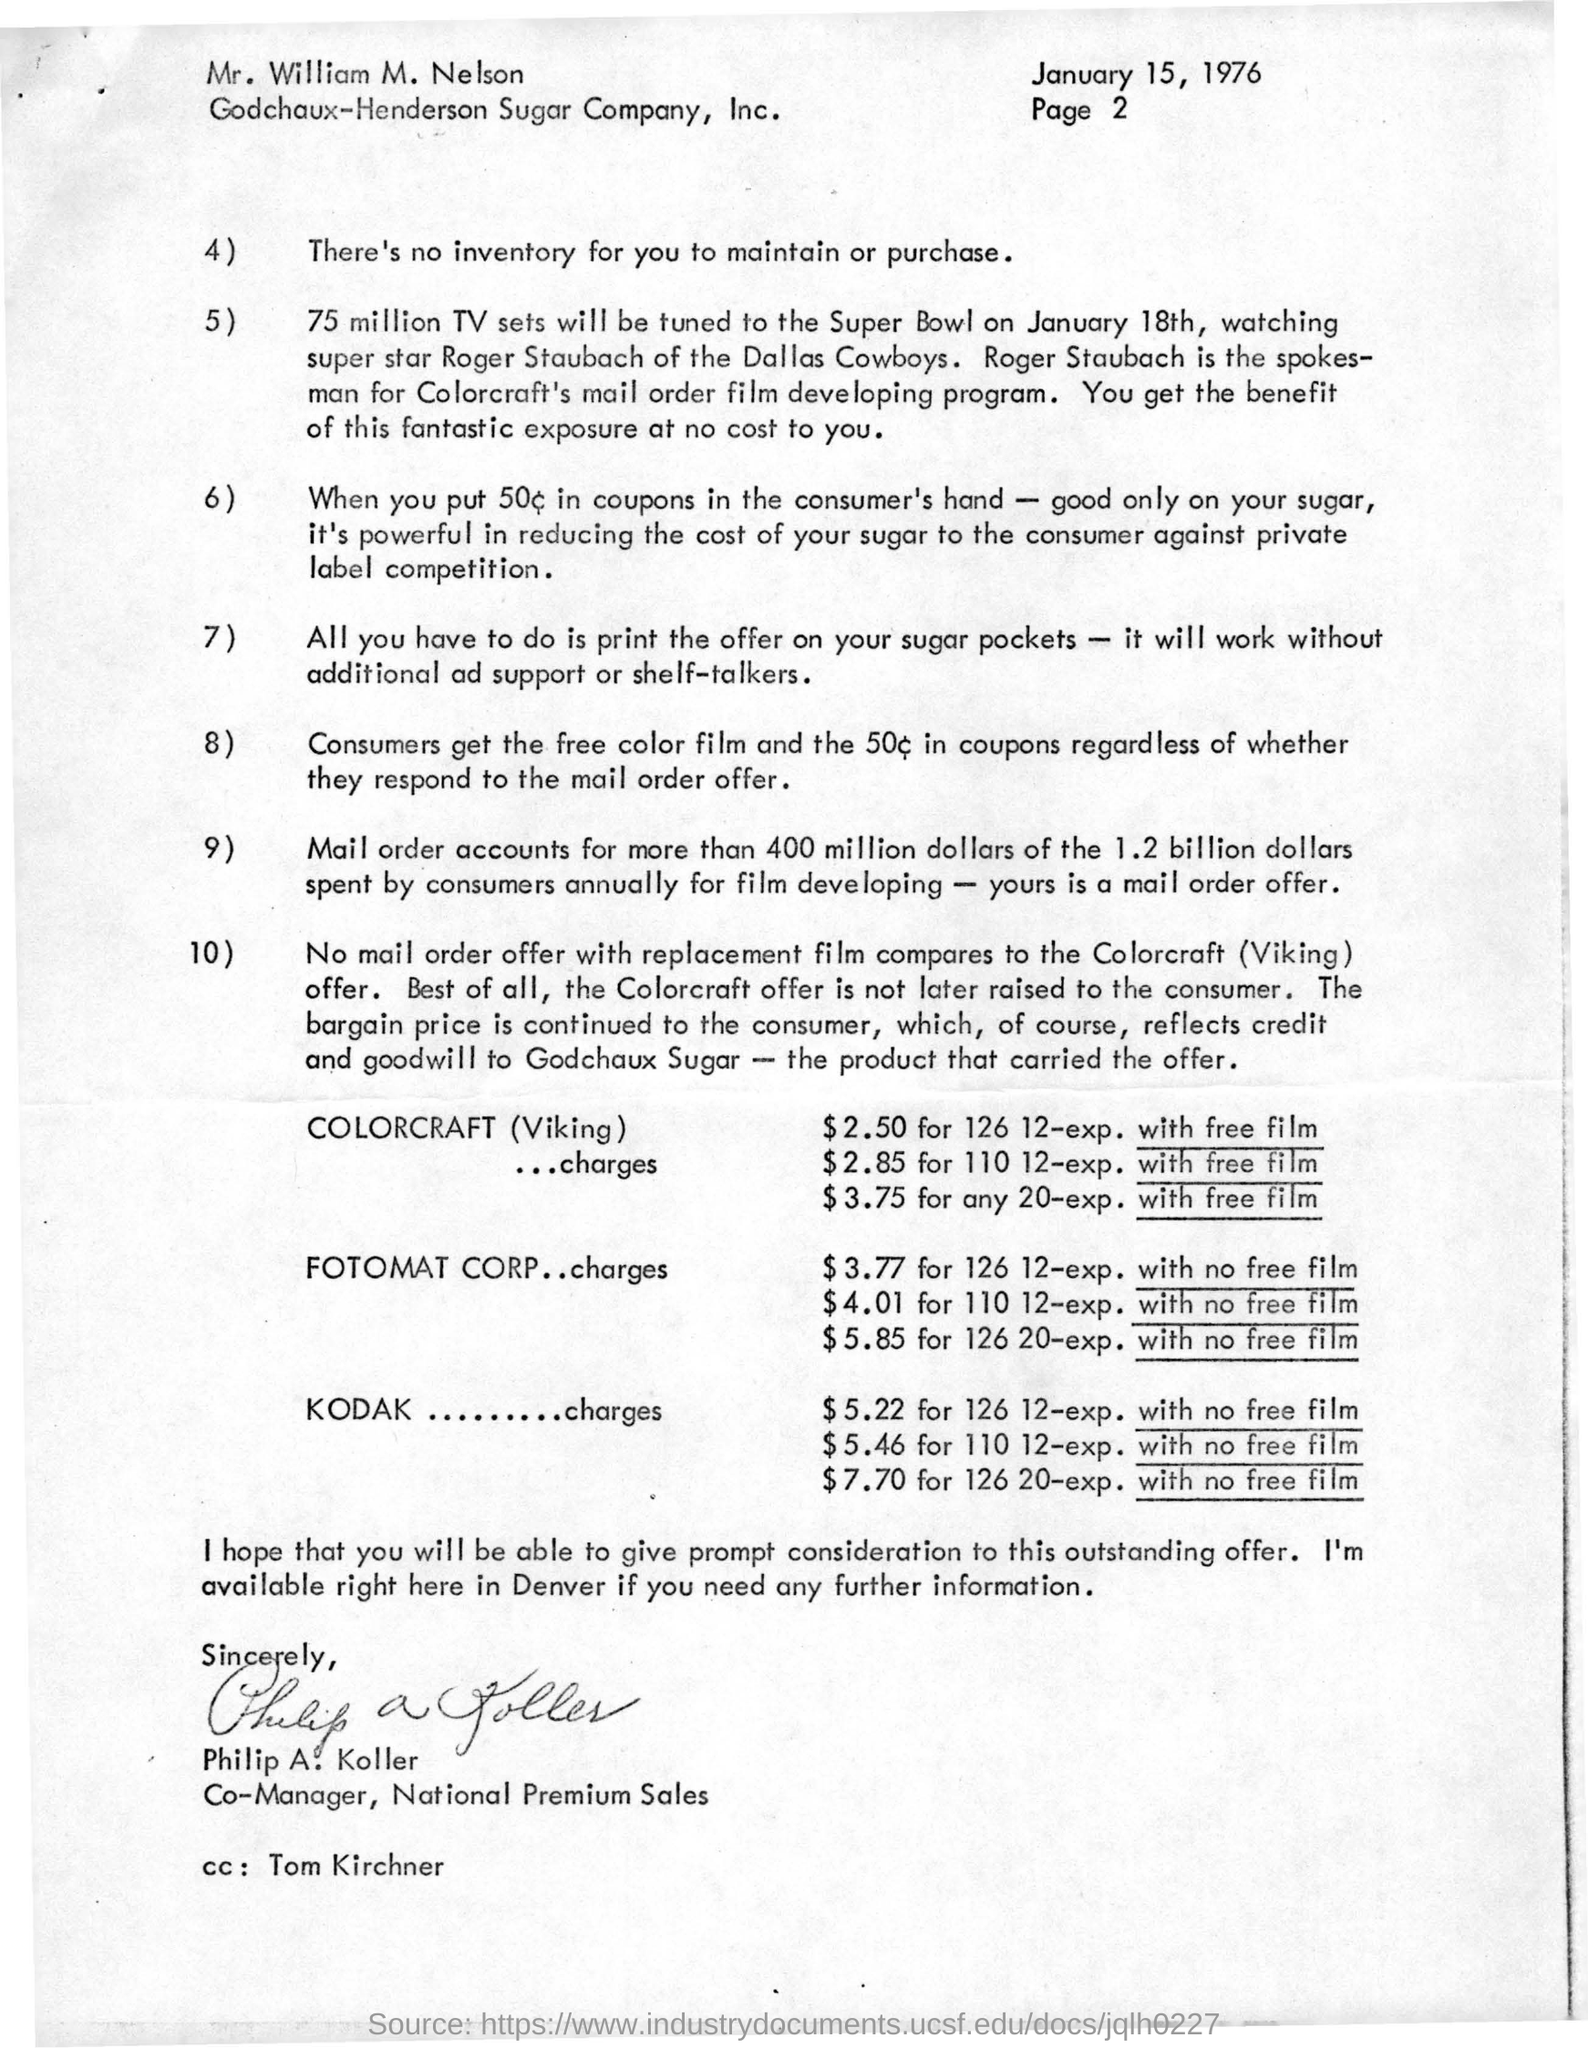Who is the spokesman for Colorcraft's mail order film developing program?
Ensure brevity in your answer.  Roger Staubach. To Whom is this letter addressed to?
Provide a succinct answer. Mr. William M. Nelson. Who wrote this letter?
Offer a terse response. Philip A. Koller. 